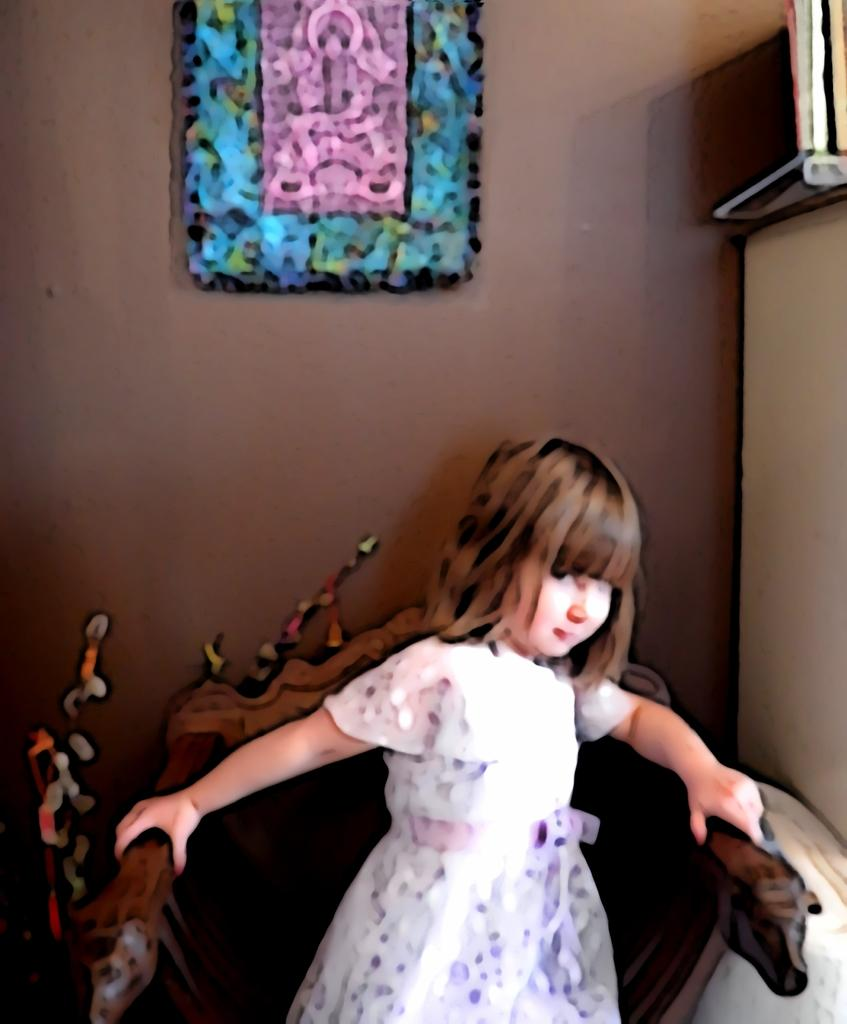What is the main subject of the image? There is a child in the image. What is the child doing in the image? The child is sitting on a chair. What can be seen in the background of the image? There is a wall in the background of the image. Is there anything on the wall in the image? Yes, there is a poster on the wall. What type of poison is the child using in the image? There is no poison present in the image; the child is simply sitting on a chair. 